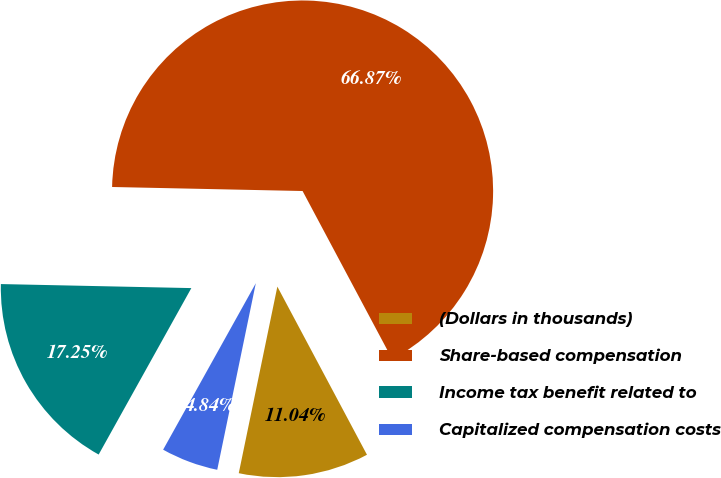Convert chart. <chart><loc_0><loc_0><loc_500><loc_500><pie_chart><fcel>(Dollars in thousands)<fcel>Share-based compensation<fcel>Income tax benefit related to<fcel>Capitalized compensation costs<nl><fcel>11.04%<fcel>66.87%<fcel>17.25%<fcel>4.84%<nl></chart> 